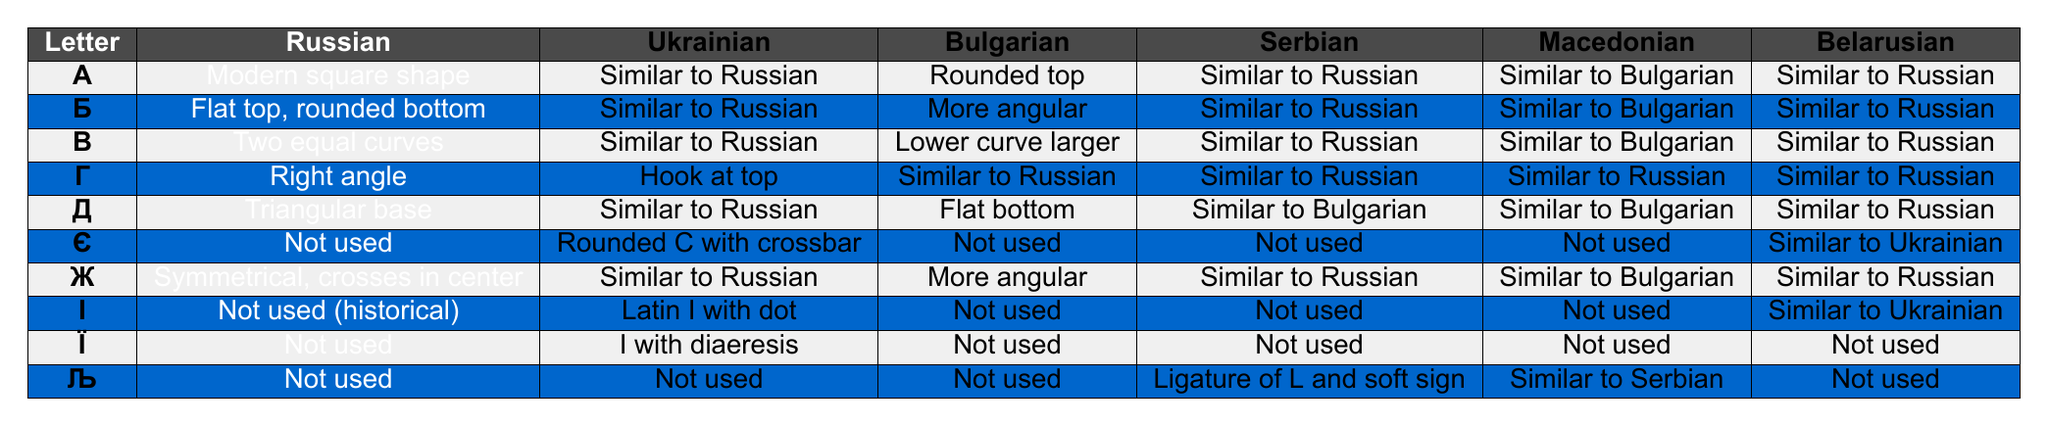What is the shape description of the letter "Г" in Russian? According to the table, the letter "Г" is described as having a "Right angle" shape in Russian.
Answer: Right angle Which languages share a similar letter shape for "Ж"? The table shows that Russian, Ukrainian, Serbian, and Belarusian all describe the letter "Ж" as "Similar to Russian." Bulgarian and Macedonian, however, describe it as "More angular" and "Similar to Bulgarian," respectively.
Answer: Russian, Ukrainian, Serbian, Belarusian Is the letter "Є" used in Bulgarian? The table indicates that the letter "Є" is marked as "Not used" in Bulgarian.
Answer: No What is the difference in the shape of the letter "Д" between Bulgarian and Russian? The shape of the letter "Д" in Russian is described as a "Triangular base," while in Bulgarian, it is a "Flat bottom." This indicates a distinct difference in their shapes.
Answer: Triangular base vs. Flat bottom Which letter has a unique shape in Ukrainian that is not found in the other listed languages? The letter "Є" has a unique shape described as a "Rounded C with crossbar" in Ukrainian, while it is not used in Russian, Bulgarian, Serbian, or Macedonian.
Answer: Є Are any letters in Ukrainian represented differently than in Russian? Yes, the table shows that the letter "І" is represented as "Latin I with dot" in Ukrainian and is marked as "Not used (historical)" in Russian.
Answer: Yes Considering the shapes of the letters, which Slavic languages have a similar description for the letter "Б"? The letter "Б" in Russian is described as "Flat top, rounded bottom," and this is also categorized as "Similar to Russian" in Ukrainian and Serbian. Bulgarian is noted for being "More angular," and Macedonian is "Similar to Bulgarian," which shows variations.
Answer: Russian, Ukrainian, Serbian For the letter "Љ," what is its representation in Serbian? The representation of the letter "Љ" in Serbian is described as a "Ligature of L and soft sign."
Answer: Ligature of L and soft sign Which two letters are marked as "Not used" across all Slavic languages except for Belarusian? According to the table, the letters "Є" and "Ї" are both marked as "Not used" across all languages except for Belarusian, which states "Similar to Ukrainian."
Answer: Є and Ї What is the shape of the letter "І" in Belarusian? The table indicates that for the letter "І," Belarusian describes it as "Similar to Ukrainian," which corresponds to its representation as "Latin I with dot" in Ukrainian.
Answer: Similar to Ukrainian 